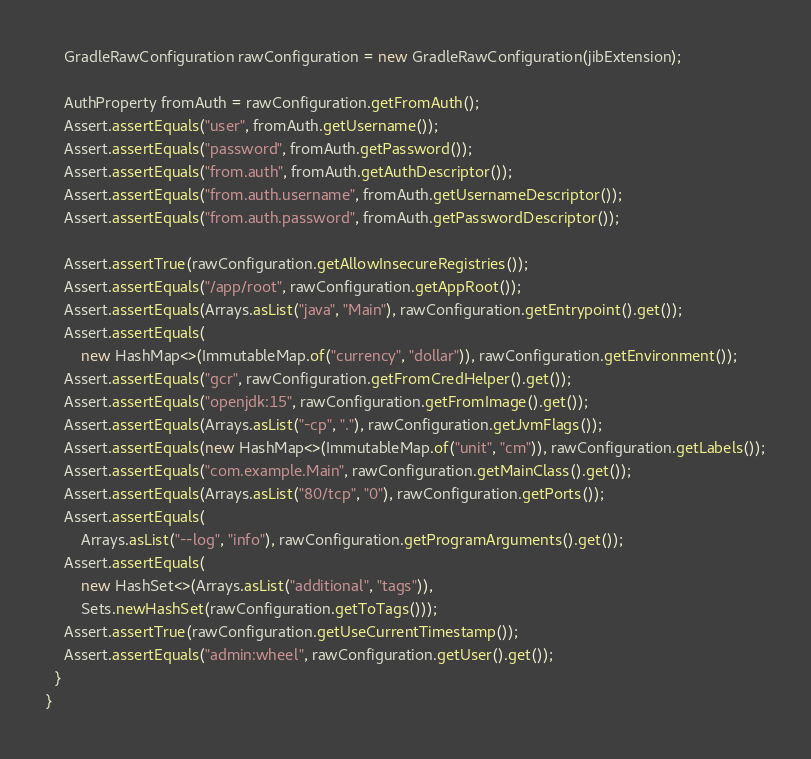Convert code to text. <code><loc_0><loc_0><loc_500><loc_500><_Java_>    GradleRawConfiguration rawConfiguration = new GradleRawConfiguration(jibExtension);

    AuthProperty fromAuth = rawConfiguration.getFromAuth();
    Assert.assertEquals("user", fromAuth.getUsername());
    Assert.assertEquals("password", fromAuth.getPassword());
    Assert.assertEquals("from.auth", fromAuth.getAuthDescriptor());
    Assert.assertEquals("from.auth.username", fromAuth.getUsernameDescriptor());
    Assert.assertEquals("from.auth.password", fromAuth.getPasswordDescriptor());

    Assert.assertTrue(rawConfiguration.getAllowInsecureRegistries());
    Assert.assertEquals("/app/root", rawConfiguration.getAppRoot());
    Assert.assertEquals(Arrays.asList("java", "Main"), rawConfiguration.getEntrypoint().get());
    Assert.assertEquals(
        new HashMap<>(ImmutableMap.of("currency", "dollar")), rawConfiguration.getEnvironment());
    Assert.assertEquals("gcr", rawConfiguration.getFromCredHelper().get());
    Assert.assertEquals("openjdk:15", rawConfiguration.getFromImage().get());
    Assert.assertEquals(Arrays.asList("-cp", "."), rawConfiguration.getJvmFlags());
    Assert.assertEquals(new HashMap<>(ImmutableMap.of("unit", "cm")), rawConfiguration.getLabels());
    Assert.assertEquals("com.example.Main", rawConfiguration.getMainClass().get());
    Assert.assertEquals(Arrays.asList("80/tcp", "0"), rawConfiguration.getPorts());
    Assert.assertEquals(
        Arrays.asList("--log", "info"), rawConfiguration.getProgramArguments().get());
    Assert.assertEquals(
        new HashSet<>(Arrays.asList("additional", "tags")),
        Sets.newHashSet(rawConfiguration.getToTags()));
    Assert.assertTrue(rawConfiguration.getUseCurrentTimestamp());
    Assert.assertEquals("admin:wheel", rawConfiguration.getUser().get());
  }
}
</code> 